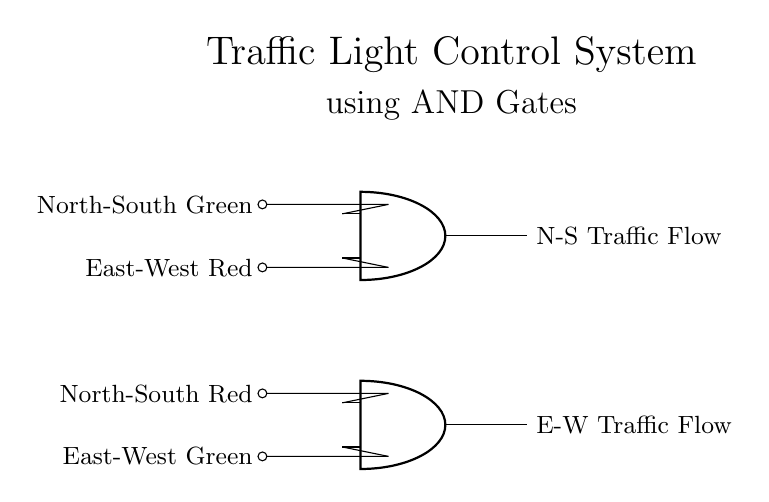What components are in the traffic light control system? The circuit includes two AND gates and four input signals representing the traffic light states for both directions.
Answer: AND gates and traffic light signals How many input signals are connected to each AND gate? Each AND gate has two input signals connected to it, coming from the traffic light states.
Answer: Two What is the output of the first AND gate? The first AND gate's output represents the north-south traffic flow when both inputs (north-south green and east-west red) are true.
Answer: North-South Traffic Flow Why are AND gates used for the traffic light control system? AND gates ensure both conditions at an intersection are met; for north-south flow to occur, the north-south green must be on while east-west red is on.
Answer: To ensure safe traffic control What happens if the east-west green signal is active? If the east-west green signal is active, the second AND gate will determine if east-west traffic can flow based on the north-south red signal being also active.
Answer: East-West Traffic Flow gets activated Which signal combination will trigger the E-W Traffic Flow output? The East-West Traffic Flow output will be triggered when the East-West Green is active and the North-South Red signal is also active, aligning both conditions.
Answer: East-West Green and North-South Red 